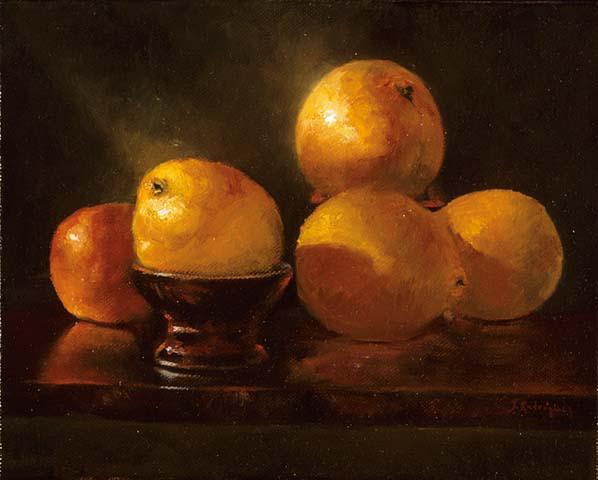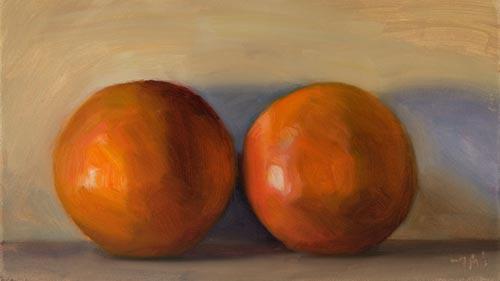The first image is the image on the left, the second image is the image on the right. Given the left and right images, does the statement "In at least on of the images, bunches of grapes are sitting on a table near some oranges." hold true? Answer yes or no. No. The first image is the image on the left, the second image is the image on the right. Examine the images to the left and right. Is the description "One image shows a peeled orange with its peel loosely around it, in front of a bunch of grapes." accurate? Answer yes or no. No. 